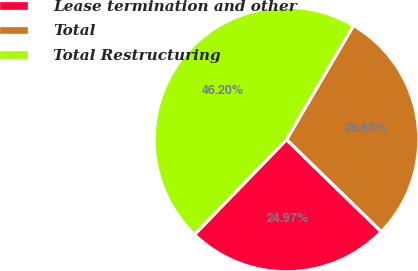<chart> <loc_0><loc_0><loc_500><loc_500><pie_chart><fcel>Lease termination and other<fcel>Total<fcel>Total Restructuring<nl><fcel>24.97%<fcel>28.83%<fcel>46.2%<nl></chart> 